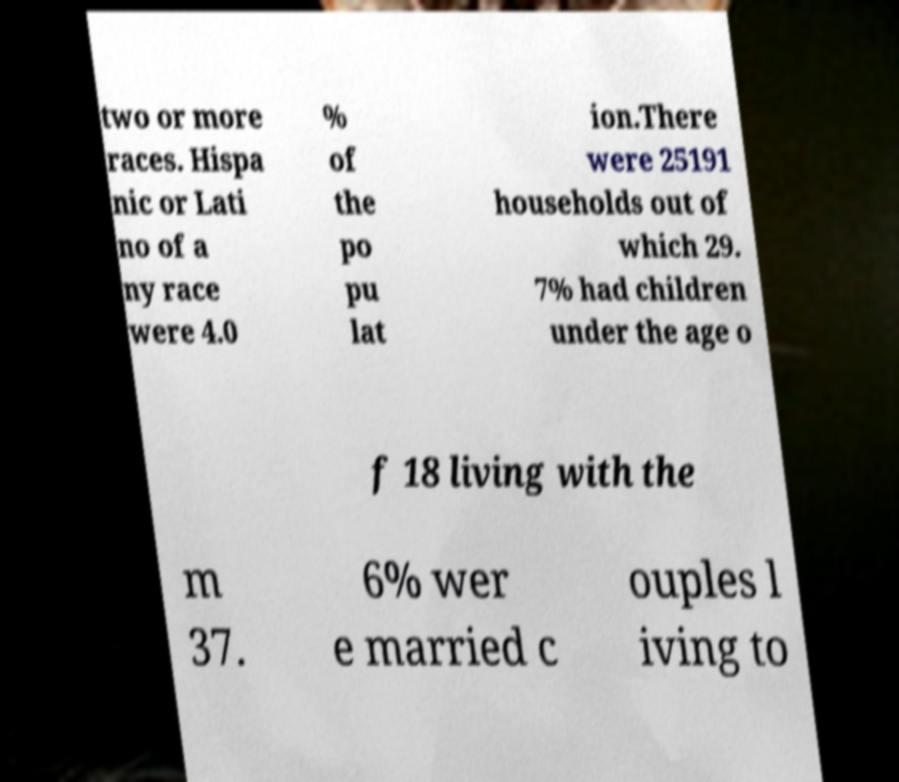Please read and relay the text visible in this image. What does it say? two or more races. Hispa nic or Lati no of a ny race were 4.0 % of the po pu lat ion.There were 25191 households out of which 29. 7% had children under the age o f 18 living with the m 37. 6% wer e married c ouples l iving to 